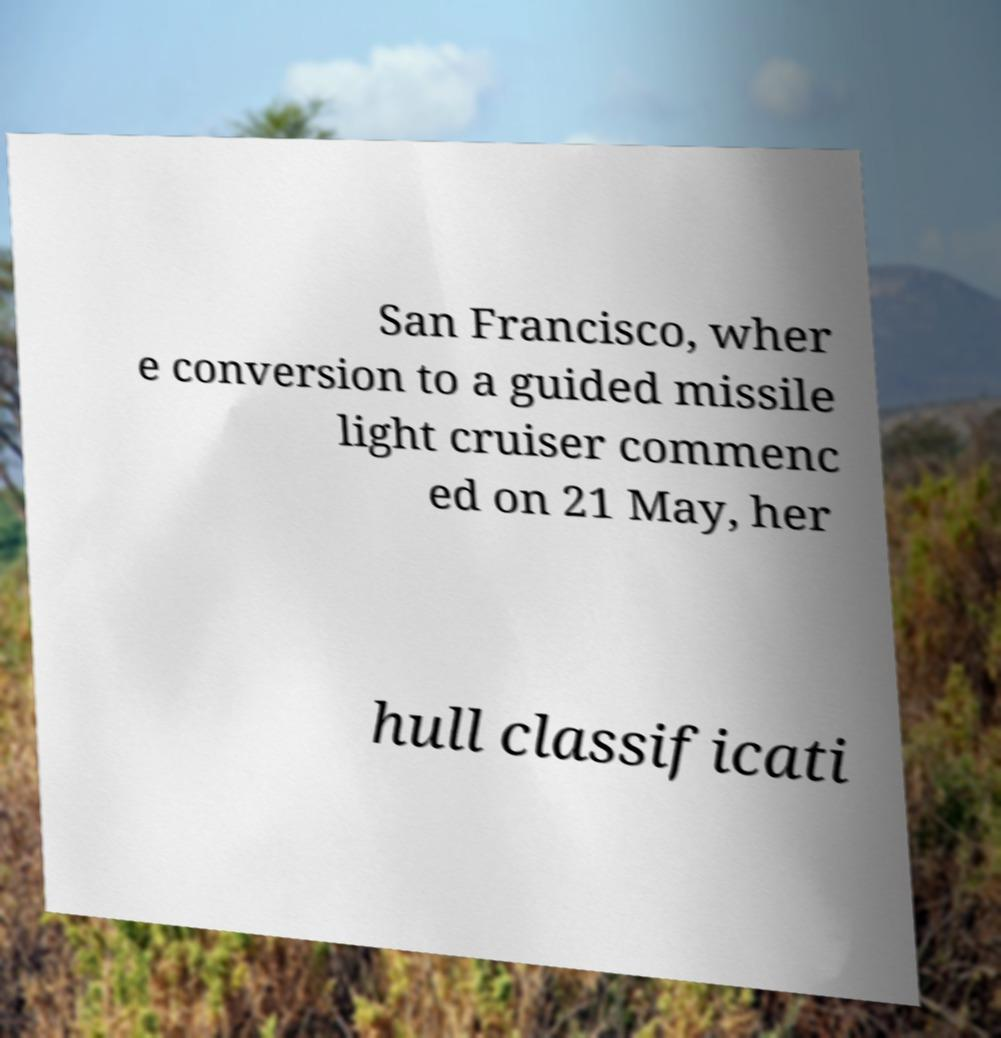There's text embedded in this image that I need extracted. Can you transcribe it verbatim? San Francisco, wher e conversion to a guided missile light cruiser commenc ed on 21 May, her hull classificati 